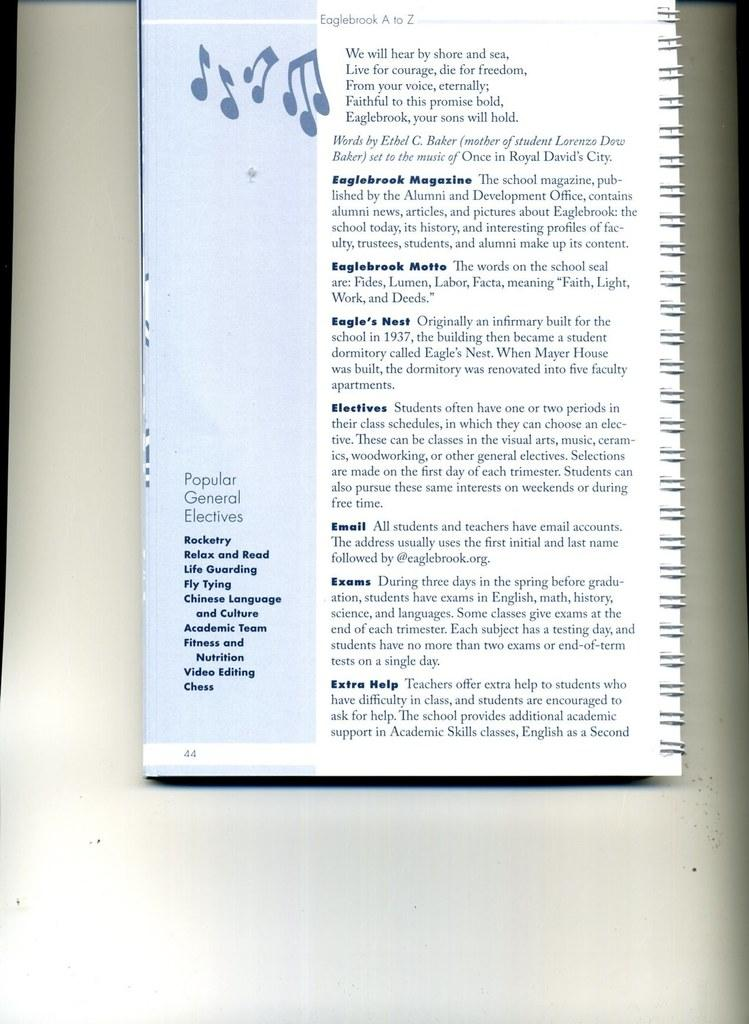<image>
Relay a brief, clear account of the picture shown. A book titled Eaglebrook A to Z features words from Ethel C baker 